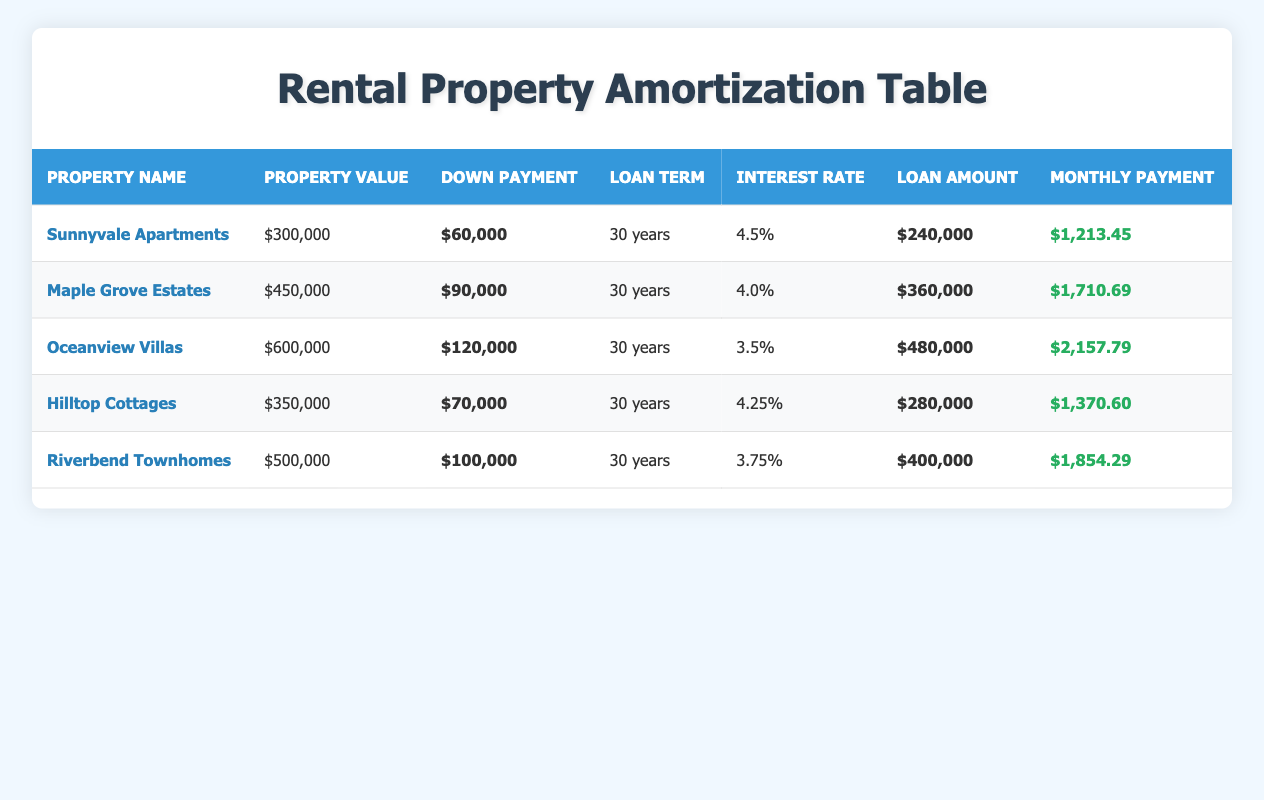What is the loan amount for Oceanview Villas? The loan amount is stated in the table directly under the column "Loan Amount" for Oceanview Villas. This amounts to $480,000.
Answer: $480,000 Which property has the highest monthly payment? By comparing the "Monthly Payment" values listed in the table, Oceanview Villas shows the highest monthly payment at $2,157.79.
Answer: Oceanview Villas What is the total down payment made across all properties? The sum of the down payments can be calculated by adding the values: $60,000 + $90,000 + $120,000 + $70,000 + $100,000 = $440,000.
Answer: $440,000 Is the interest rate for Riverbend Townhomes lower than 4.5%? Checking the interest rate for Riverbend Townhomes in the table, it is 3.75%, which is indeed lower than 4.5%.
Answer: Yes What is the difference in loan amounts between Maple Grove Estates and Hilltop Cottages? The loan amount for Maple Grove Estates is $360,000, while for Hilltop Cottages it is $280,000. The difference is calculated as $360,000 - $280,000 = $80,000.
Answer: $80,000 Which property has the lowest property value and what is that value? The property with the lowest property value is Sunnyvale Apartments listed at $300,000 according to the "Property Value" column in the table.
Answer: $300,000 If the down payment for Oceanview Villas was increased by $30,000, what would the new loan amount be? Oceanview Villas has a current down payment of $120,000. Increasing this by $30,000 results in a $150,000 down payment. The new loan amount is calculated as $600,000 (property value) - $150,000 (new down payment) = $450,000.
Answer: $450,000 Is the monthly payment for Hilltop Cottages higher than $1,400? For Hilltop Cottages, the monthly payment is listed as $1,370.60, which means it is not higher than $1,400.
Answer: No 